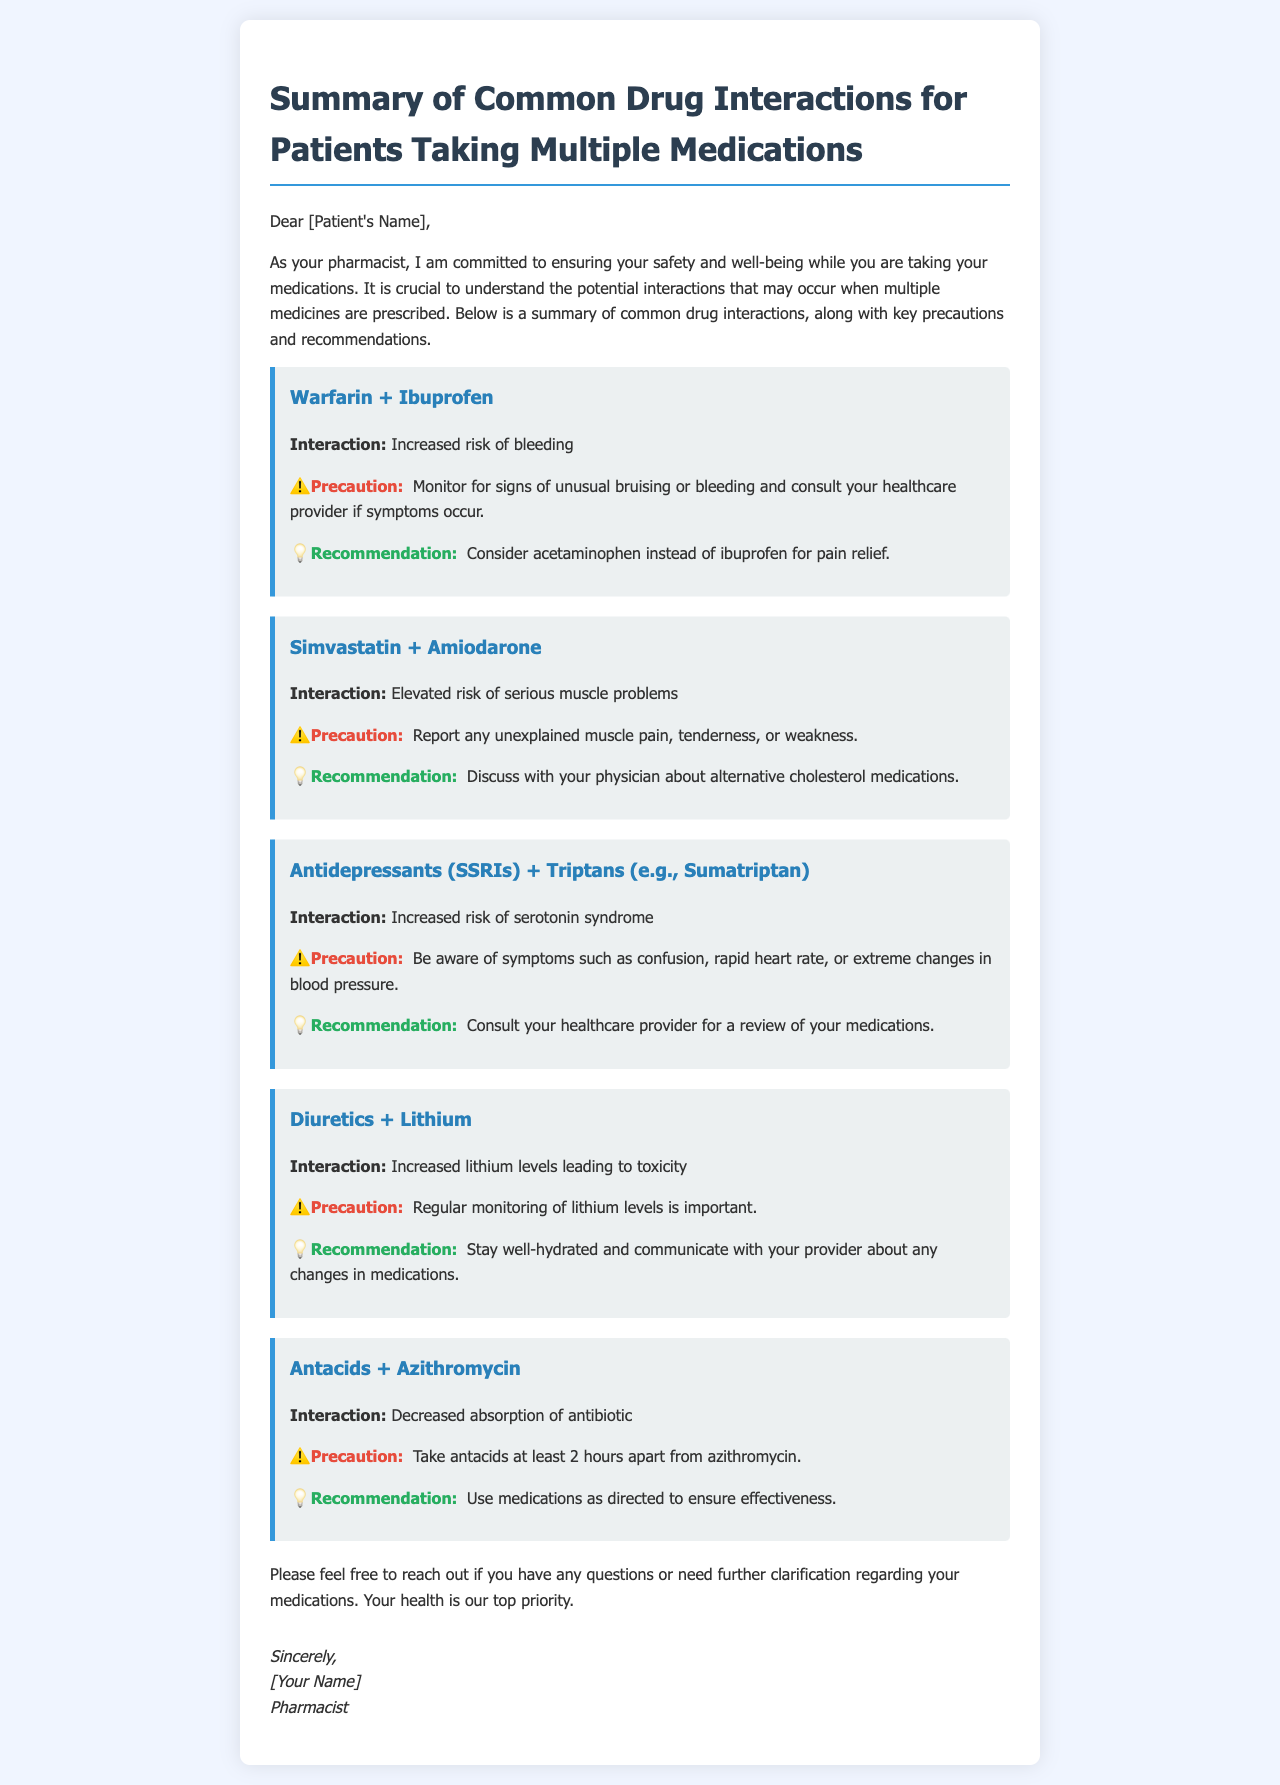What is the main purpose of the letter? The letter aims to ensure the patient's safety and well-being while taking medications by summarizing common drug interactions.
Answer: Ensuring safety and well-being What medication should be considered instead of ibuprofen? The letter recommends an alternative medication for pain relief due to the risk of bleeding with warfarin and ibuprofen.
Answer: Acetaminophen What serious condition is associated with the interaction of simvastatin and amiodarone? The interaction description highlights a specific health issue that patients should be aware of when taking these two medications.
Answer: Serious muscle problems How far apart should antacids be taken from azithromycin? The document specifies an important timing aspect regarding medication administration to avoid interactions.
Answer: At least 2 hours What symptoms should lithium users monitor for when taking diuretics? This question targets the precautions mentioned in the document regarding a specific medication interaction.
Answer: Lithium toxicity Which types of medications increase the risk of serotonin syndrome? The document lists specific medications that should not be mixed due to the risk of this syndrome.
Answer: Antidepressants (SSRIs) and Triptans What should you do if you experience unexplained muscle pain while on simvastatin and amiodarone? The letter advises patients on actions to take in response to certain symptoms associated with this medication combination.
Answer: Report to your healthcare provider What is the tone of the letter? The letter's overall tone is measured by its formal structure and the emphasis on patient care and safety.
Answer: Supportive and informative 